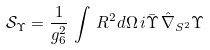Convert formula to latex. <formula><loc_0><loc_0><loc_500><loc_500>\mathcal { S } _ { \Upsilon } = \frac { 1 } { g ^ { 2 } _ { 6 } } \, \int \, R ^ { 2 } d \Omega \, i \bar { \Upsilon } \, \hat { \nabla } _ { S ^ { 2 } } \Upsilon</formula> 